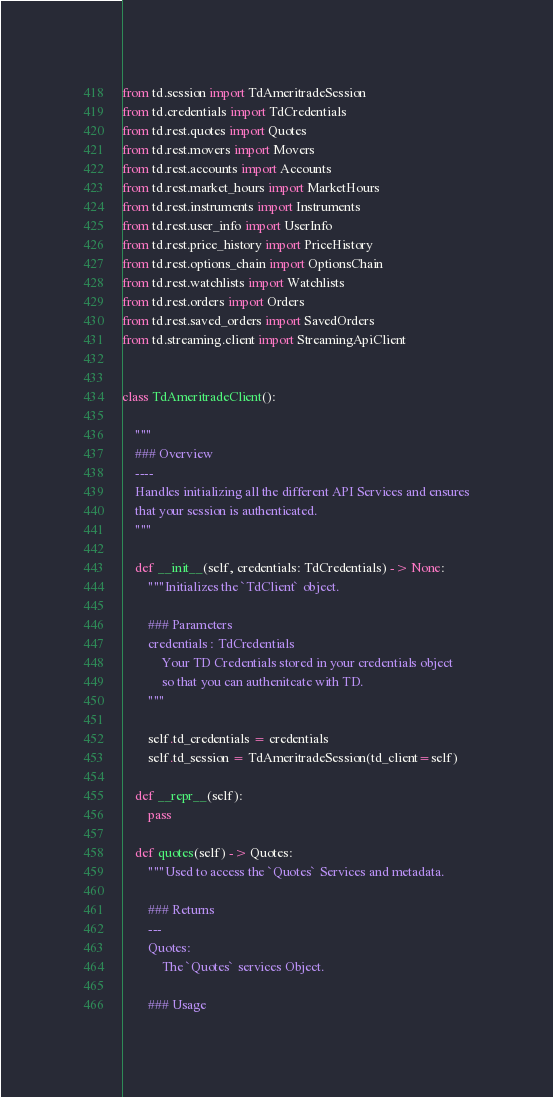Convert code to text. <code><loc_0><loc_0><loc_500><loc_500><_Python_>from td.session import TdAmeritradeSession
from td.credentials import TdCredentials
from td.rest.quotes import Quotes
from td.rest.movers import Movers
from td.rest.accounts import Accounts
from td.rest.market_hours import MarketHours
from td.rest.instruments import Instruments
from td.rest.user_info import UserInfo
from td.rest.price_history import PriceHistory
from td.rest.options_chain import OptionsChain
from td.rest.watchlists import Watchlists
from td.rest.orders import Orders
from td.rest.saved_orders import SavedOrders
from td.streaming.client import StreamingApiClient


class TdAmeritradeClient():

    """
    ### Overview
    ----
    Handles initializing all the different API Services and ensures
    that your session is authenticated.
    """

    def __init__(self, credentials: TdCredentials) -> None:
        """Initializes the `TdClient` object.

        ### Parameters
        credentials : TdCredentials
            Your TD Credentials stored in your credentials object
            so that you can authenitcate with TD.
        """

        self.td_credentials = credentials
        self.td_session = TdAmeritradeSession(td_client=self)

    def __repr__(self):
        pass

    def quotes(self) -> Quotes:
        """Used to access the `Quotes` Services and metadata.

        ### Returns
        ---
        Quotes:
            The `Quotes` services Object.

        ### Usage</code> 